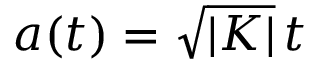Convert formula to latex. <formula><loc_0><loc_0><loc_500><loc_500>a ( t ) = \sqrt { | K | } \, t</formula> 